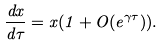<formula> <loc_0><loc_0><loc_500><loc_500>\frac { d x } { d \tau } = x ( 1 + O ( e ^ { \gamma \tau } ) ) .</formula> 